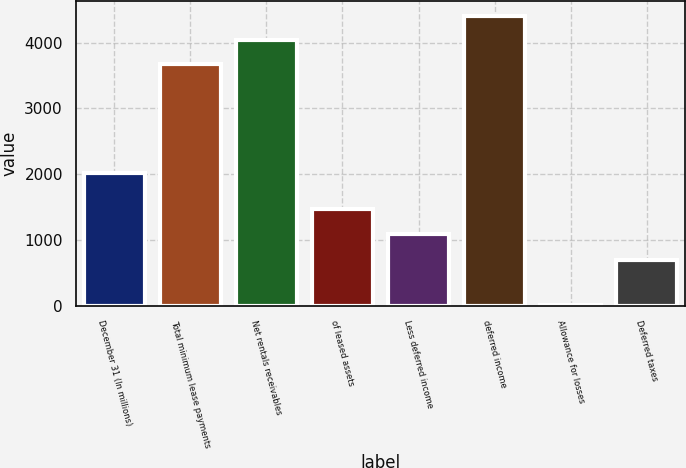<chart> <loc_0><loc_0><loc_500><loc_500><bar_chart><fcel>December 31 (In millions)<fcel>Total minimum lease payments<fcel>Net rentals receivables<fcel>of leased assets<fcel>Less deferred income<fcel>deferred income<fcel>Allowance for losses<fcel>Deferred taxes<nl><fcel>2014<fcel>3669<fcel>4038.2<fcel>1470.2<fcel>1101<fcel>4407.4<fcel>14<fcel>697<nl></chart> 